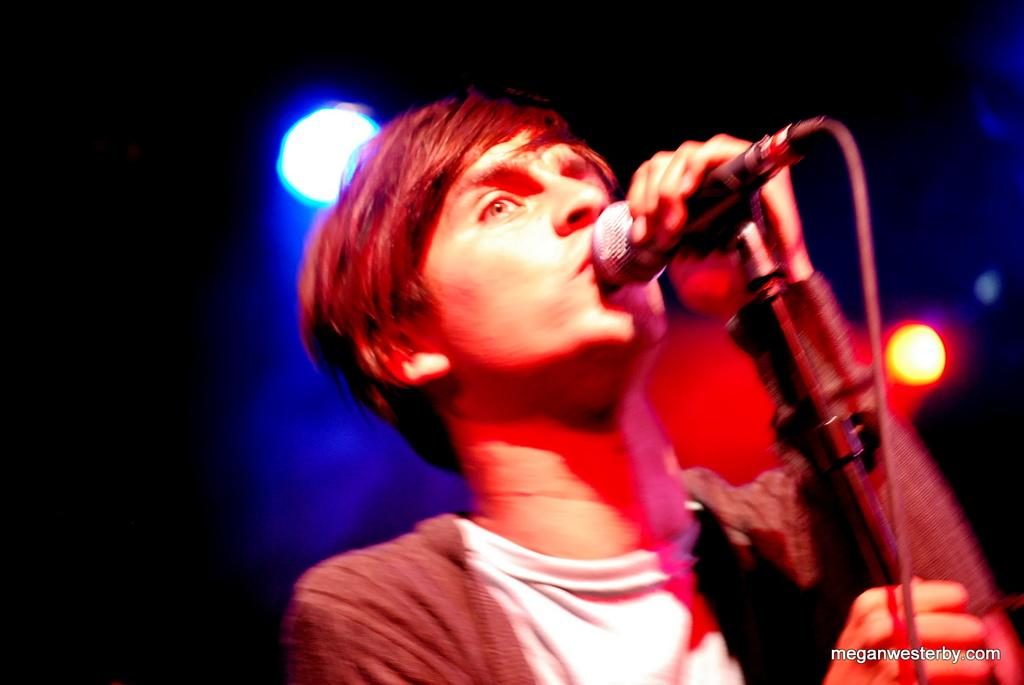What is the person in the image doing? The person is holding a microphone. What object is supporting the microphone in the image? There is a microphone stand in the image. What can be seen in the background of the image? There are lights visible in the background. What is present in the right bottom corner of the image? There is text or an image in the right bottom corner of the image. How many trucks are visible in the image? There are no trucks present in the image. What type of lawyer is standing next to the person holding the microphone? There is no lawyer present in the image. 